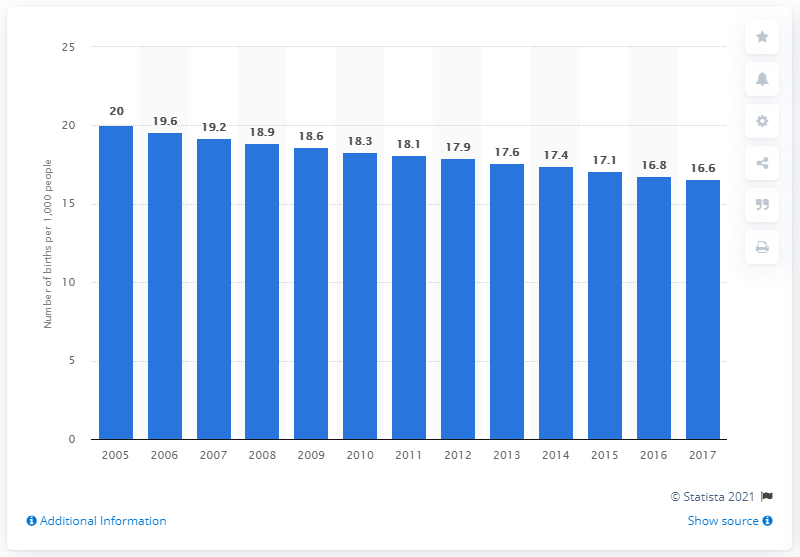List a handful of essential elements in this visual. In 2017, the average number of live births per 1,000 people in Latin America and the Caribbean was 16.6. The birth rate in Latin America and the Caribbean began to decline in 2005. 